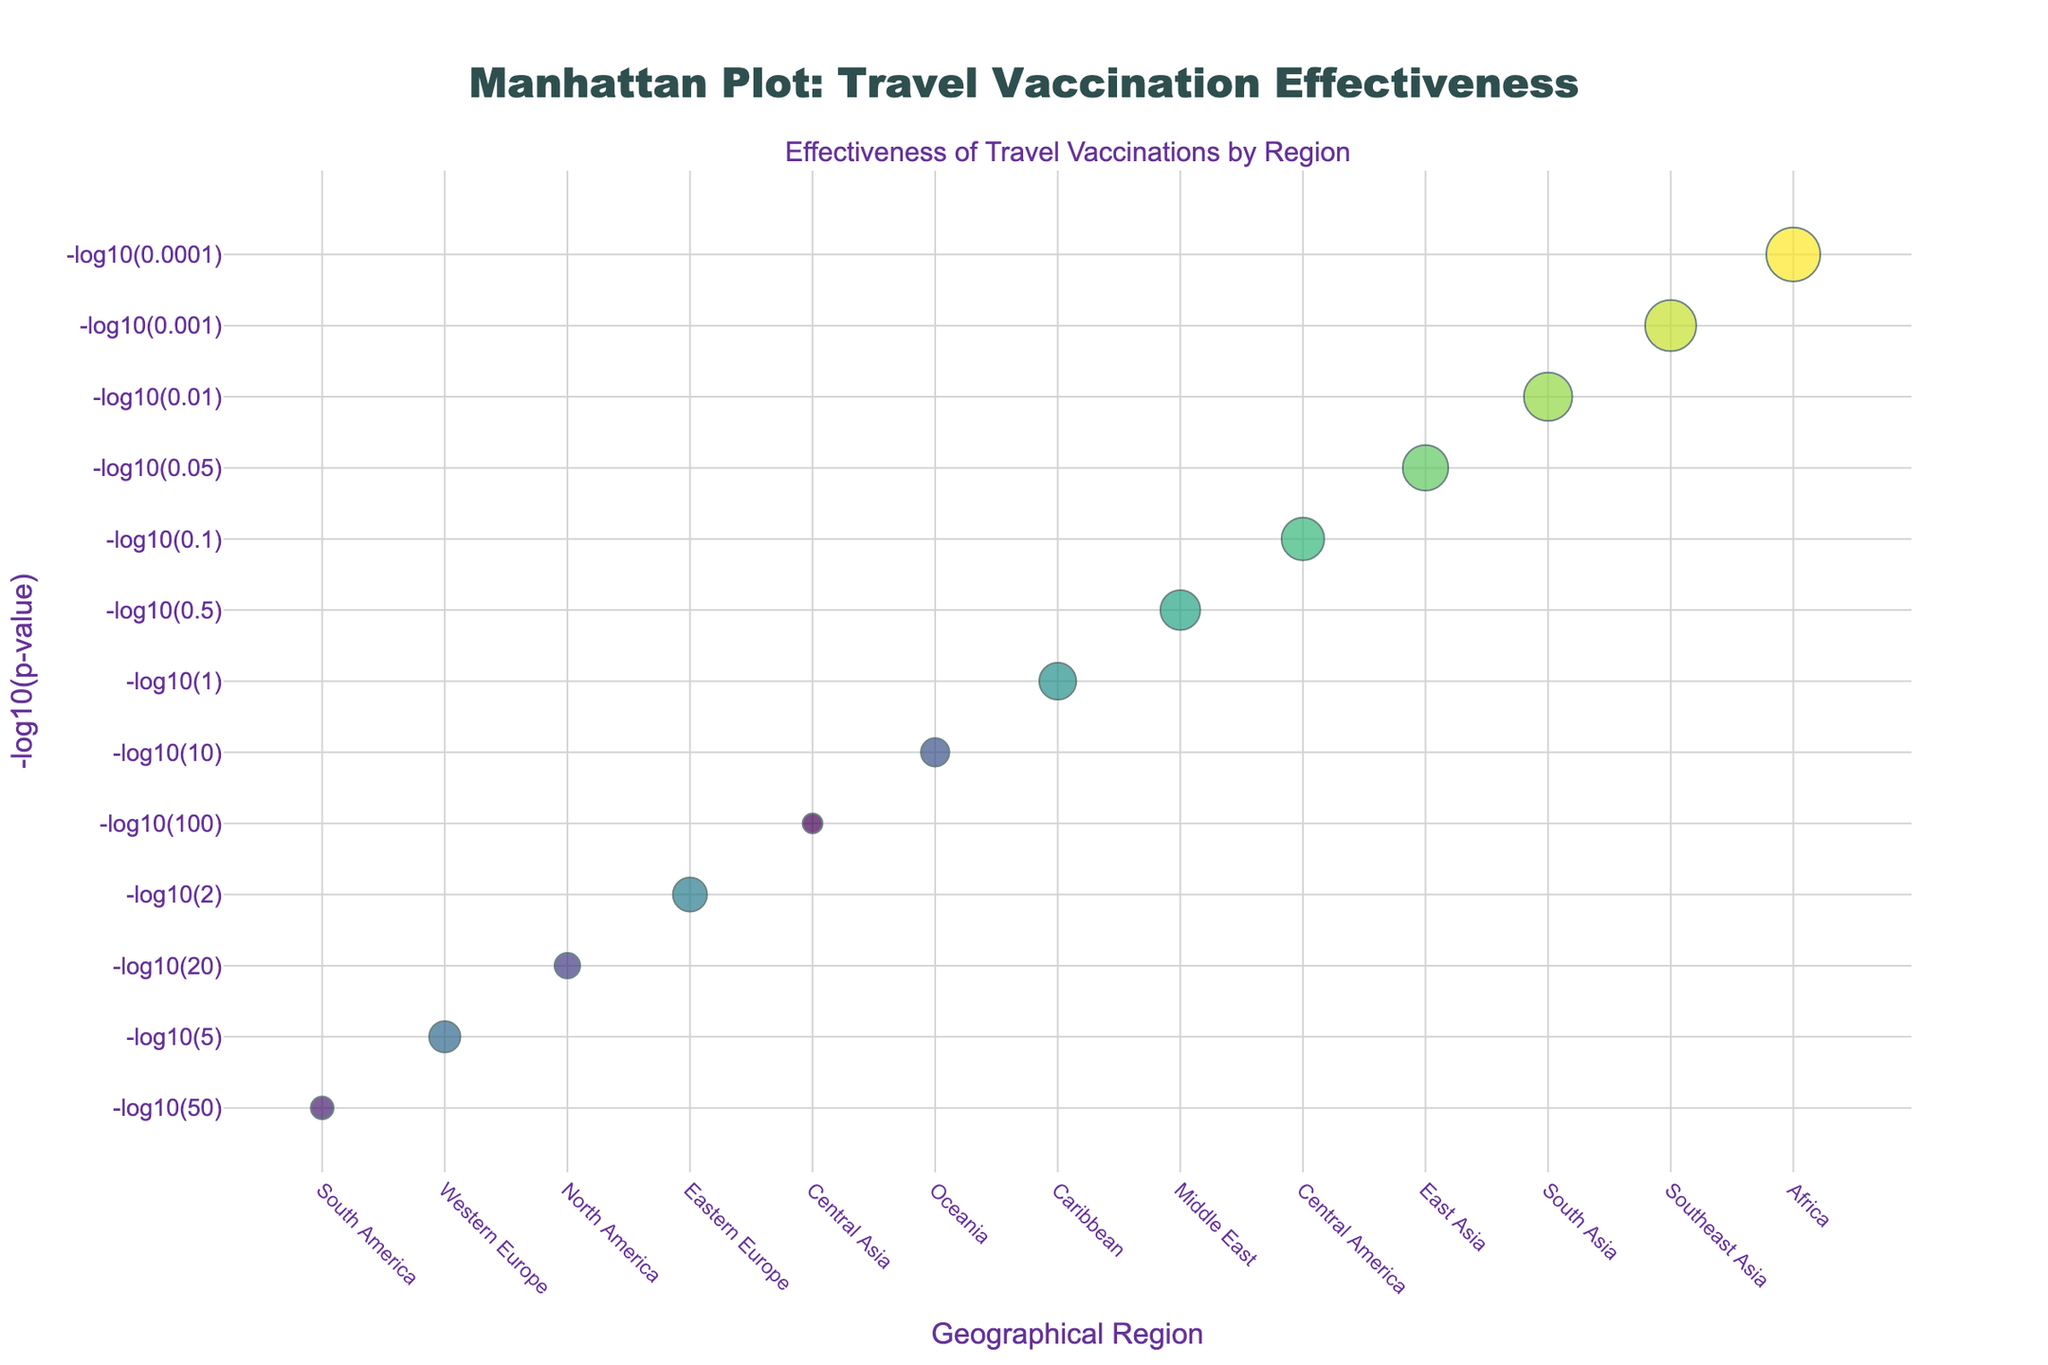What is the title of the plot? Look at the top of the plot where the main heading is displayed. The title is usually in a larger and bolder font.
Answer: Manhattan Plot: Travel Vaccination Effectiveness How many regions are listed on the x-axis? The x-axis shows the geographical regions, each being a separate category. Count the number of categories.
Answer: 13 Which vaccine has the highest effectiveness? Identify the largest marker, as effectiveness is represented by the size of the marker. Then check the tooltip or the label of that marker.
Answer: Yellow Fever Which region shows the vaccine with the smallest p-value? The smallest p-value will correspond to the highest -log10(p-value) on the y-axis. Identify the point at the top of the y-axis and check the region on the x-axis.
Answer: Africa Which region shows the least effective vaccine? Find the smallest marker, as effectiveness is represented by the size of the marker. Then check the region on the x-axis corresponding to that marker.
Answer: Central Asia What is the -log10(p-value) for the Hepatitis A vaccine? Locate the marker associated with 'Hepatitis A' by checking the text or tooltip along the x-axis (Southeast Asia), then read the y-axis value corresponding to that marker.
Answer: 3 How does the effectiveness of Rabies compare to Influenza? Identify the markers for Rabies (Central America) and Influenza (Western Europe). Compare their sizes, since effectiveness is represented by marker size.
Answer: Rabies is more effective than Influenza What is the region with the second-highest -log10(p-value)? Identify the second highest point (just below the highest) on the y-axis and check the region label on the x-axis.
Answer: Southeast Asia Calculate the average effectiveness of the vaccines listed from regions Africa, Southeast Asia, and South Asia. Find the effectiveness values for Africa (95), Southeast Asia (90), and South Asia (85). Add them and divide by 3. (95 + 90 + 85) / 3
Answer: 90 Which vaccine has the highest -log10(p-value) and what is its effectiveness? Highest -log10(p-value) means the point furthest up the y-axis. Identify this point and check the label/tooltip for the vaccine name and corresponding effectiveness.
Answer: Yellow Fever, 95 